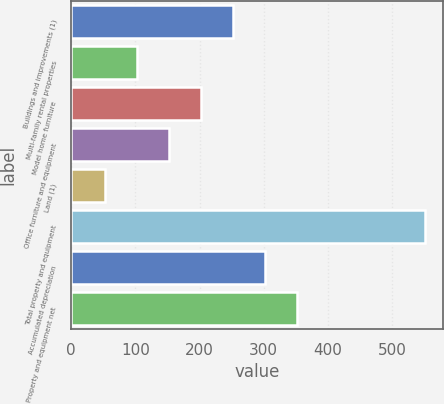Convert chart. <chart><loc_0><loc_0><loc_500><loc_500><bar_chart><fcel>Buildings and improvements (1)<fcel>Multi-family rental properties<fcel>Model home furniture<fcel>Office furniture and equipment<fcel>Land (1)<fcel>Total property and equipment<fcel>Accumulated depreciation<fcel>Property and equipment net<nl><fcel>252.22<fcel>102.73<fcel>202.39<fcel>152.56<fcel>52.9<fcel>551.2<fcel>302.05<fcel>351.88<nl></chart> 